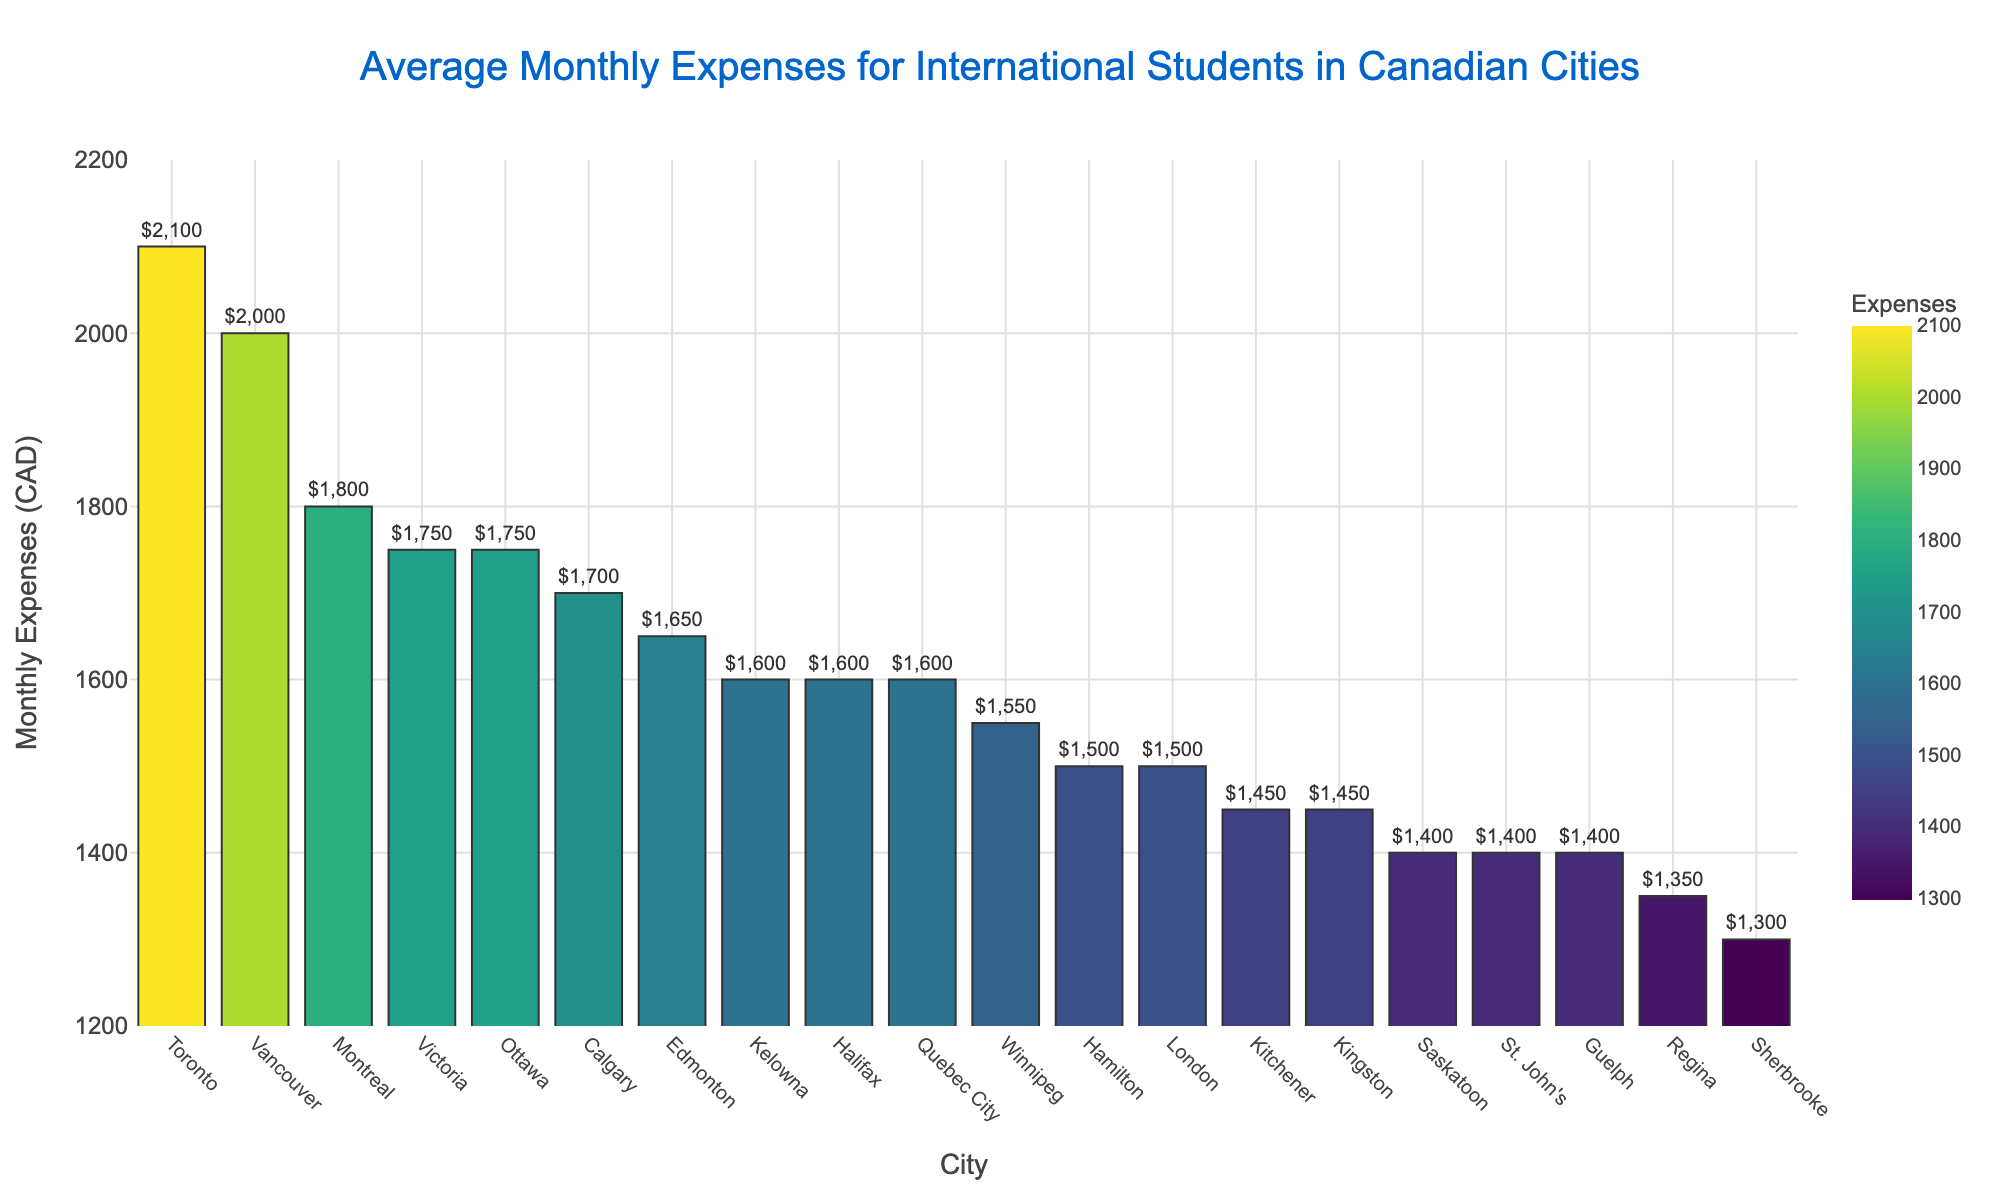Which city has the highest average monthly expenses for international students? The bar chart shows the average monthly expenses for international students across Canadian cities. The city with the highest bar, which also has the darkest color, represents the highest expenses. In this case, Toronto has the highest average monthly expenses.
Answer: Toronto Which city has the lowest average monthly expenses for international students? The bar chart shows the average monthly expenses for international students across Canadian cities. The city with the shortest bar, which also has the lightest color, represents the lowest expenses. Sherbrooke has the lowest average monthly expenses.
Answer: Sherbrooke How much more are the average monthly expenses in Vancouver compared to Calgary? The bar for Vancouver is taller than the bar for Calgary. Subtract the expenses for Calgary from those for Vancouver: 2000 CAD (Vancouver) - 1700 CAD (Calgary) = 300 CAD.
Answer: 300 CAD What is the total monthly expense for international students in Montreal and Ottawa combined? Add the average monthly expenses for Montreal and Ottawa: 1800 CAD (Montreal) + 1750 CAD (Ottawa) = 3550 CAD.
Answer: 3550 CAD How do the expenses in Victoria and Halifax compare? Both Victoria and Halifax have average monthly expenses of 1750 CAD. The bars are of equal height and color.
Answer: Equal Which cities have an average monthly expense of 1600 CAD? By inspecting the heights and colors corresponding to the 1600 CAD value on the y-axis, the cities with this expense are Quebec City, Halifax, and Kelowna.
Answer: Quebec City, Halifax, Kelowna What is the average of the monthly expenses for Edmonton, Winnipeg, and Hamilton? Add the monthly expenses for Edmonton, Winnipeg, and Hamilton and then divide by 3: (1650 CAD + 1550 CAD + 1500 CAD) / 3 = 1566.67 CAD.
Answer: 1566.67 CAD By how much do the expenses in Toronto exceed those in Sherbrooke? Subtract the expenses for Sherbrooke from those for Toronto: 2100 CAD (Toronto) - 1300 CAD (Sherbrooke) = 800 CAD.
Answer: 800 CAD Which city is closest to the median of the average monthly expenses? Arrange the cities in ascending order by their expenses and locate the middle value(s). The median falls in the middle of the sorted list. With 20 cities, the median is the average of the 10th and 11th cities: (1600 CAD (Halifax) + 1600 CAD (Quebec City)) / 2 = 1600 CAD. Both Halifax and Quebec City can be considered.
Answer: Halifax, Quebec City 